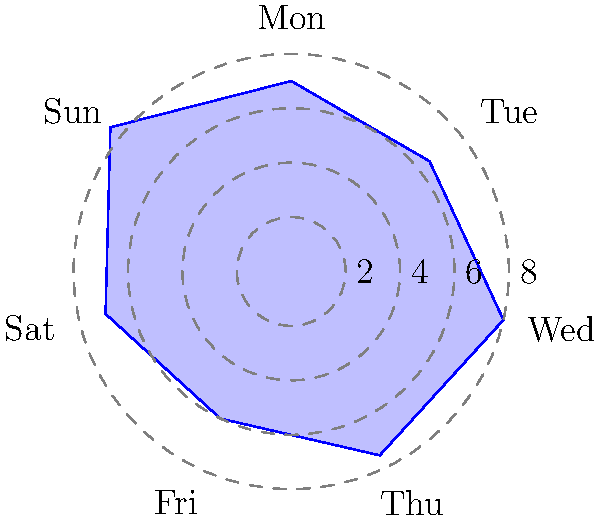As a touring musician, you've been tracking your sleep patterns using a circular sleep cycle diagram. The diagram shows your sleep duration for each day of the week, with the distance from the center representing hours of sleep. If you aim to average 7.5 hours of sleep per night, how many more hours of total sleep do you need to achieve this goal for the week? To solve this problem, let's follow these steps:

1. Calculate the total sleep time for the week:
   Monday: 7 hours
   Tuesday: 6.5 hours
   Wednesday: 8 hours
   Thursday: 7.5 hours
   Friday: 6 hours
   Saturday: 7 hours
   Sunday: 8.5 hours
   
   Total = 7 + 6.5 + 8 + 7.5 + 6 + 7 + 8.5 = 50.5 hours

2. Calculate the target total sleep time for the week:
   Target = 7.5 hours × 7 days = 52.5 hours

3. Calculate the difference between the target and actual sleep time:
   Difference = Target - Actual
               = 52.5 hours - 50.5 hours
               = 2 hours

Therefore, you need 2 more hours of total sleep to achieve an average of 7.5 hours per night for the week.
Answer: 2 hours 